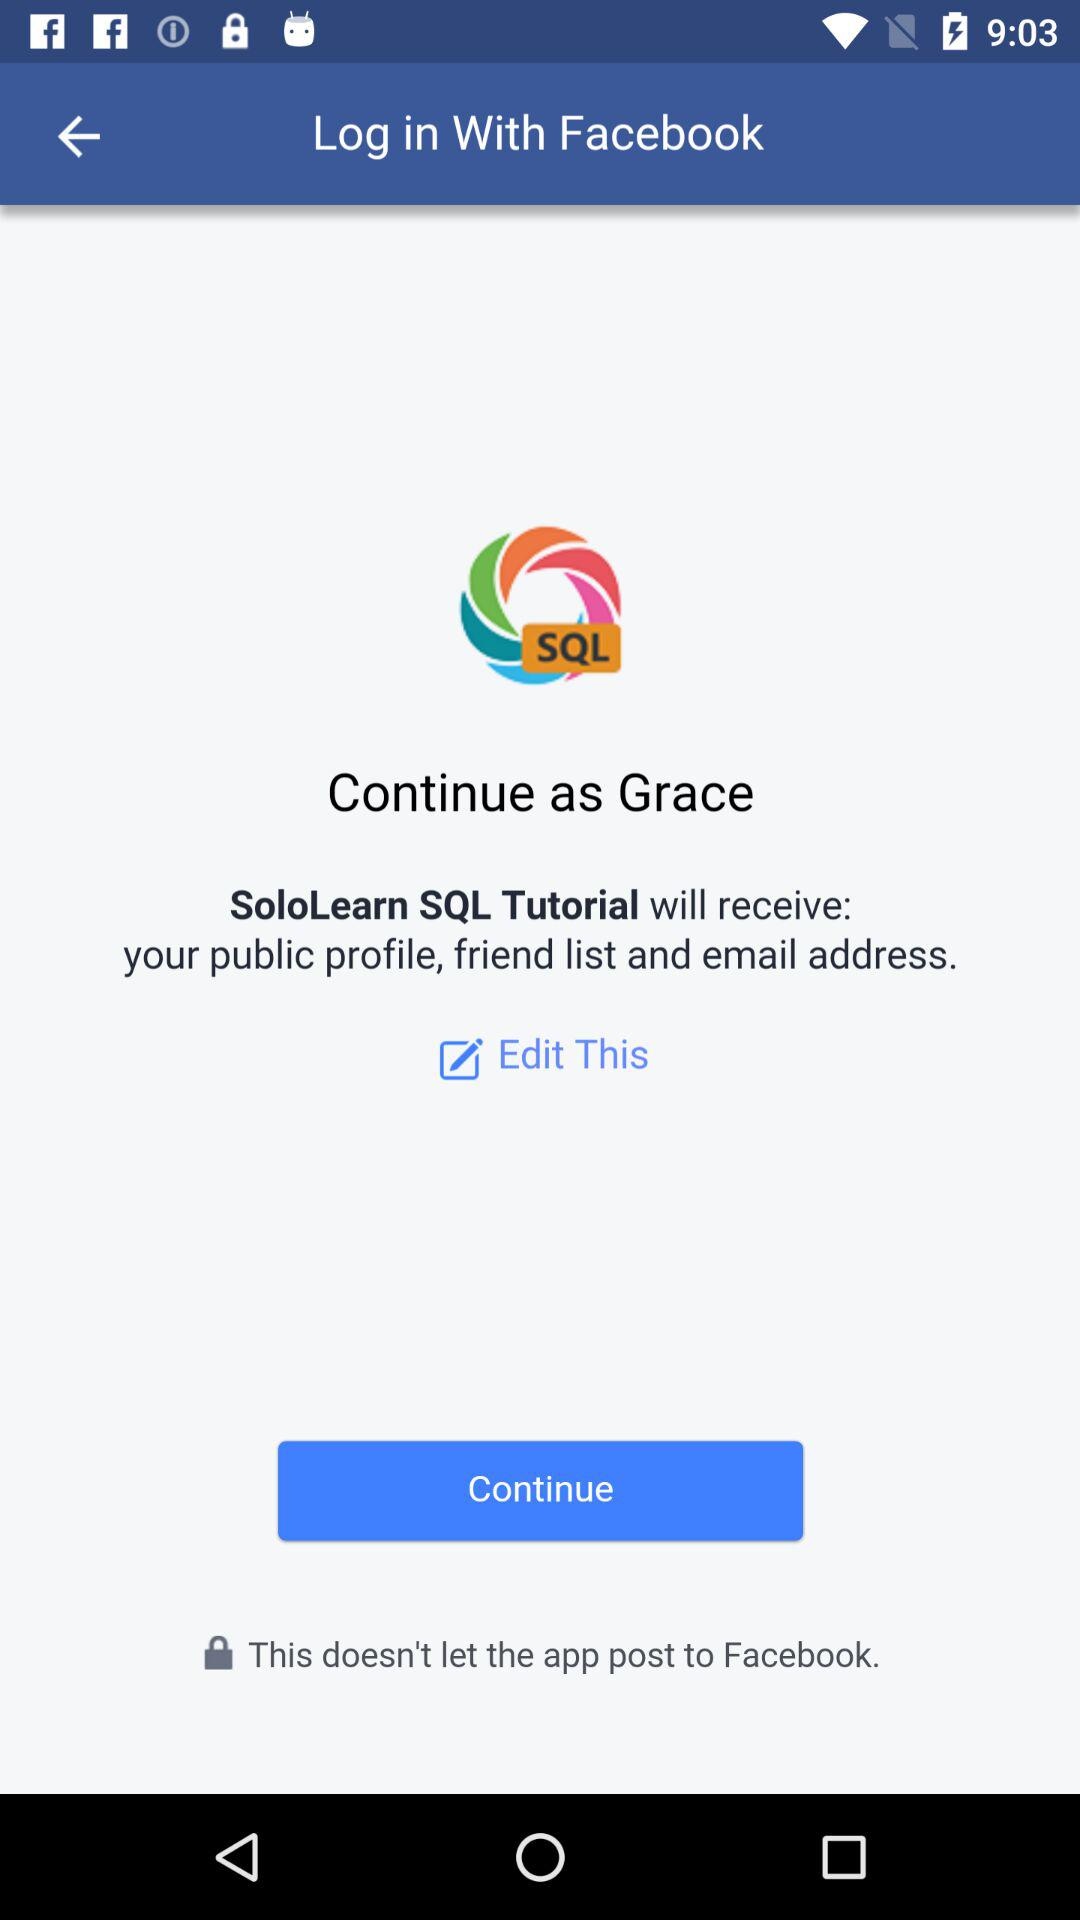What is the login name? The login name is Grace. 